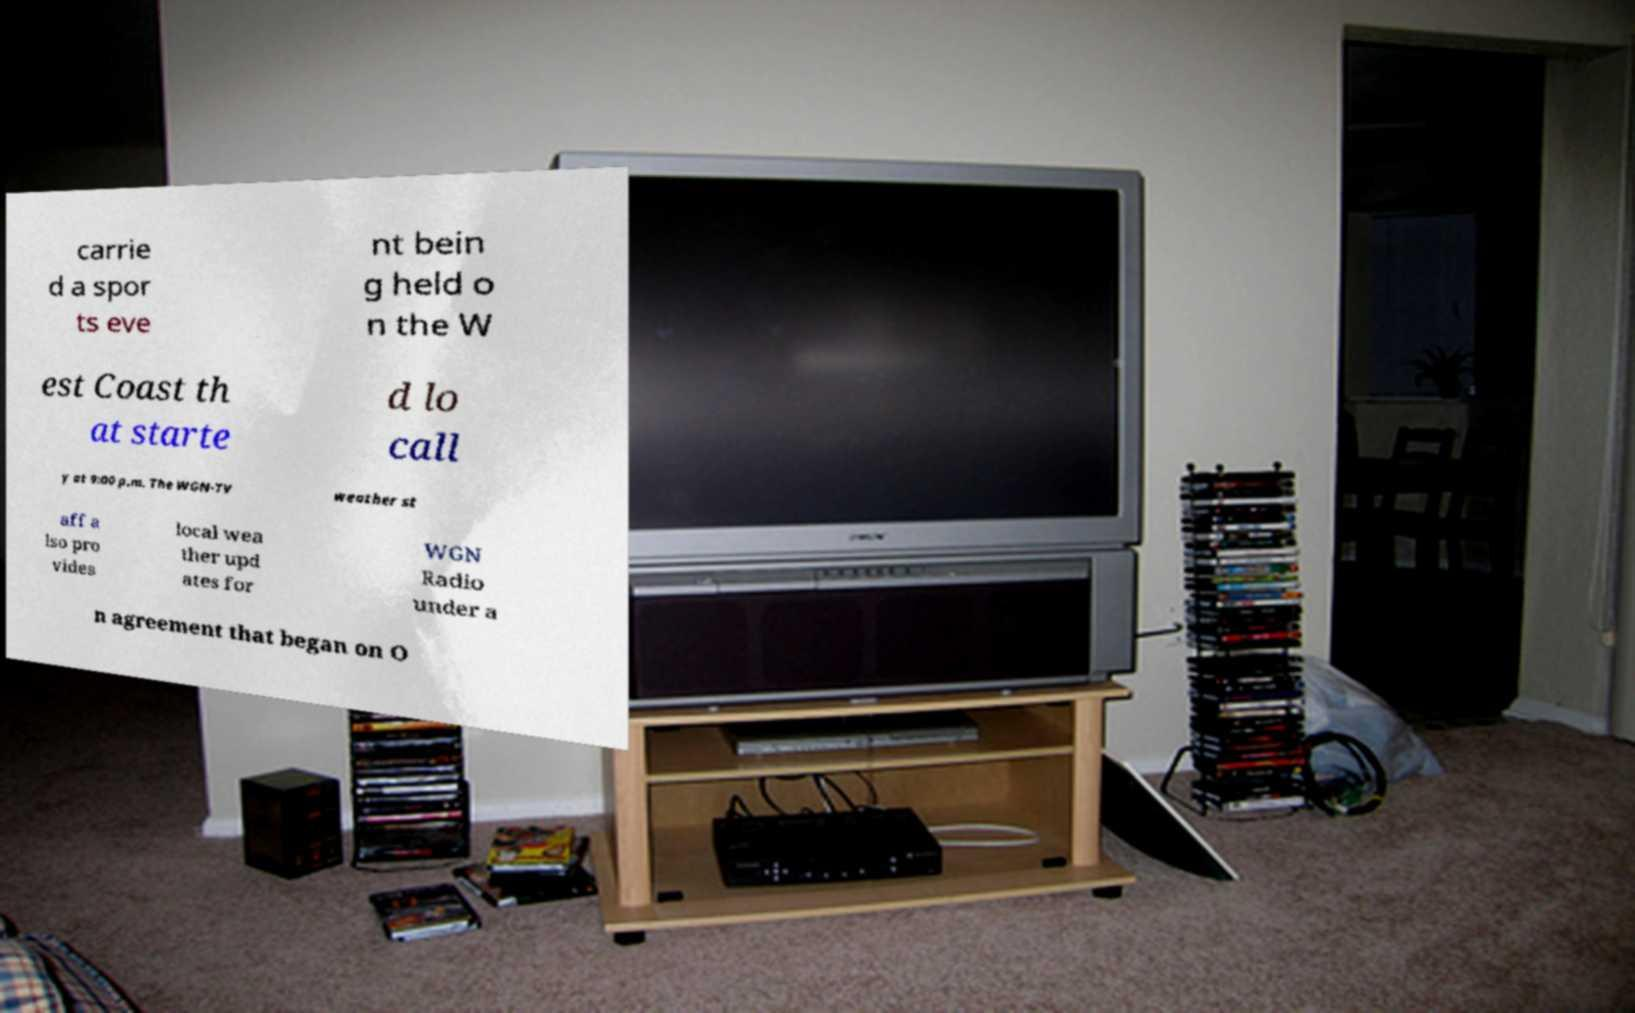Please identify and transcribe the text found in this image. carrie d a spor ts eve nt bein g held o n the W est Coast th at starte d lo call y at 9:00 p.m. The WGN-TV weather st aff a lso pro vides local wea ther upd ates for WGN Radio under a n agreement that began on O 